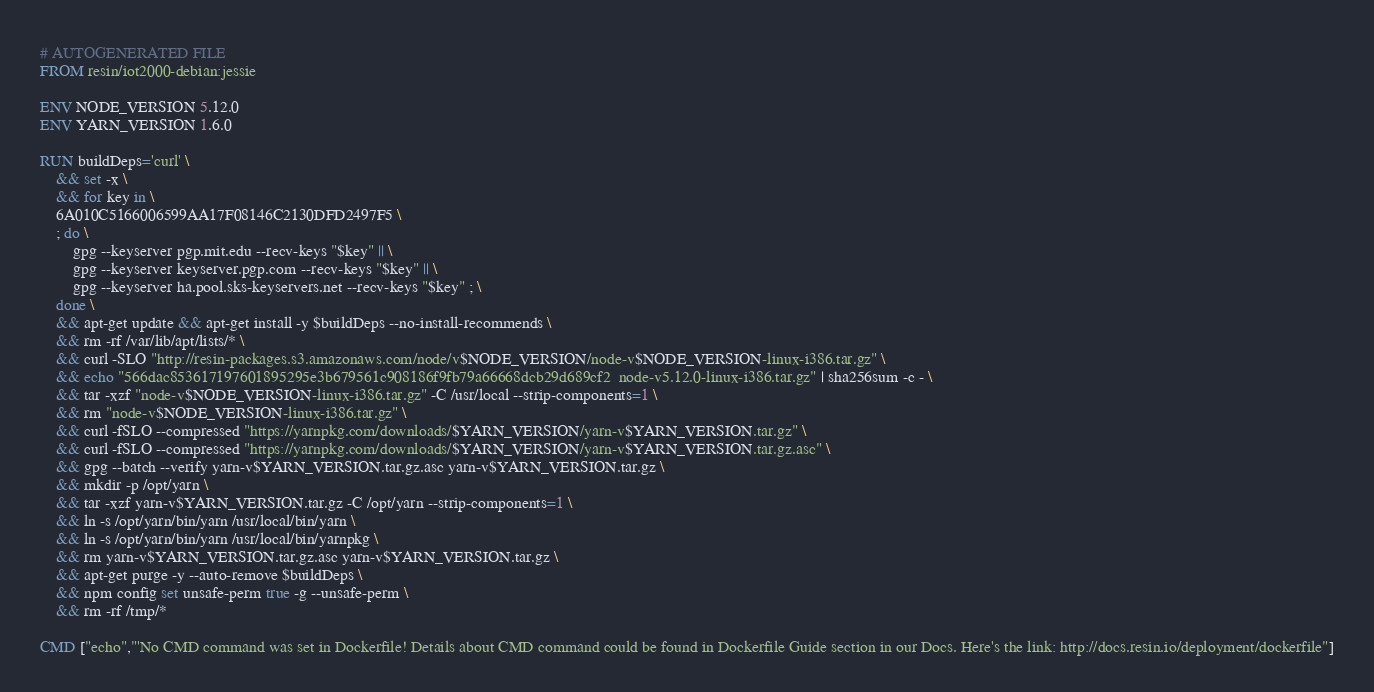<code> <loc_0><loc_0><loc_500><loc_500><_Dockerfile_># AUTOGENERATED FILE
FROM resin/iot2000-debian:jessie

ENV NODE_VERSION 5.12.0
ENV YARN_VERSION 1.6.0

RUN buildDeps='curl' \
	&& set -x \
	&& for key in \
	6A010C5166006599AA17F08146C2130DFD2497F5 \
	; do \
		gpg --keyserver pgp.mit.edu --recv-keys "$key" || \
		gpg --keyserver keyserver.pgp.com --recv-keys "$key" || \
		gpg --keyserver ha.pool.sks-keyservers.net --recv-keys "$key" ; \
	done \
	&& apt-get update && apt-get install -y $buildDeps --no-install-recommends \
	&& rm -rf /var/lib/apt/lists/* \
	&& curl -SLO "http://resin-packages.s3.amazonaws.com/node/v$NODE_VERSION/node-v$NODE_VERSION-linux-i386.tar.gz" \
	&& echo "566dac853617197601895295e3b679561c908186f9fb79a66668dcb29d689cf2  node-v5.12.0-linux-i386.tar.gz" | sha256sum -c - \
	&& tar -xzf "node-v$NODE_VERSION-linux-i386.tar.gz" -C /usr/local --strip-components=1 \
	&& rm "node-v$NODE_VERSION-linux-i386.tar.gz" \
	&& curl -fSLO --compressed "https://yarnpkg.com/downloads/$YARN_VERSION/yarn-v$YARN_VERSION.tar.gz" \
	&& curl -fSLO --compressed "https://yarnpkg.com/downloads/$YARN_VERSION/yarn-v$YARN_VERSION.tar.gz.asc" \
	&& gpg --batch --verify yarn-v$YARN_VERSION.tar.gz.asc yarn-v$YARN_VERSION.tar.gz \
	&& mkdir -p /opt/yarn \
	&& tar -xzf yarn-v$YARN_VERSION.tar.gz -C /opt/yarn --strip-components=1 \
	&& ln -s /opt/yarn/bin/yarn /usr/local/bin/yarn \
	&& ln -s /opt/yarn/bin/yarn /usr/local/bin/yarnpkg \
	&& rm yarn-v$YARN_VERSION.tar.gz.asc yarn-v$YARN_VERSION.tar.gz \
	&& apt-get purge -y --auto-remove $buildDeps \
	&& npm config set unsafe-perm true -g --unsafe-perm \
	&& rm -rf /tmp/*

CMD ["echo","'No CMD command was set in Dockerfile! Details about CMD command could be found in Dockerfile Guide section in our Docs. Here's the link: http://docs.resin.io/deployment/dockerfile"]
</code> 